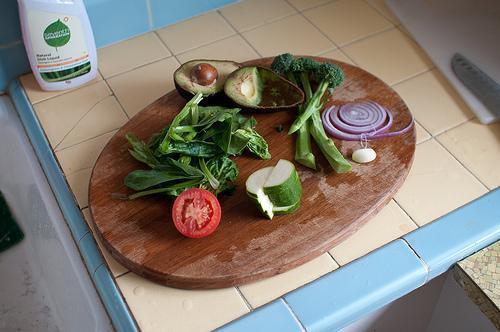How many cutting boards?
Give a very brief answer. 1. 